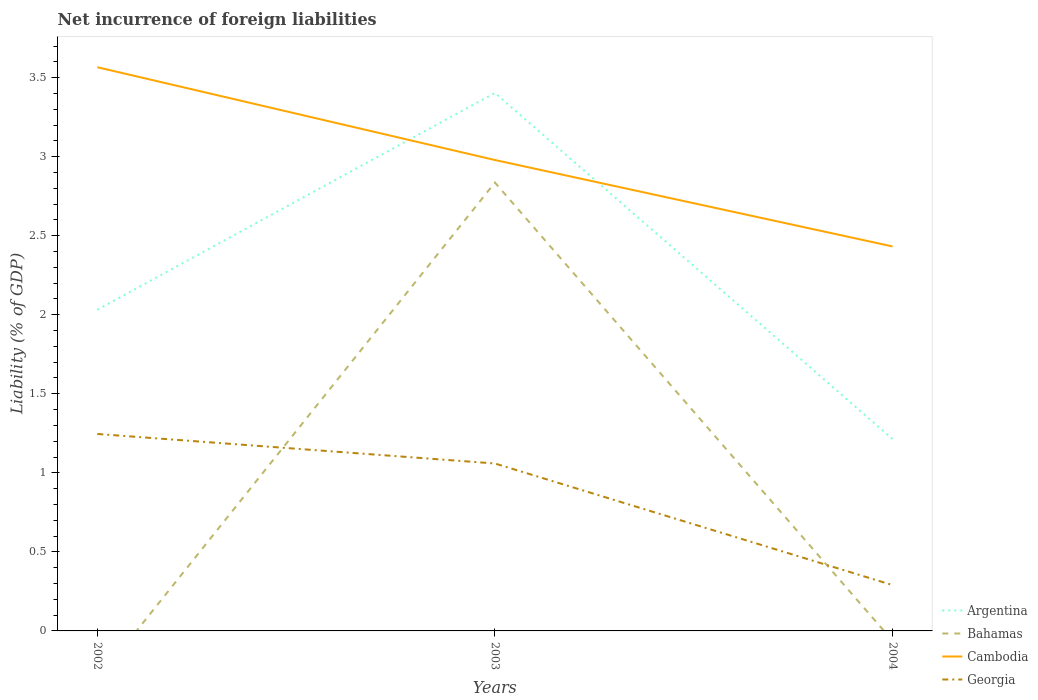Does the line corresponding to Georgia intersect with the line corresponding to Bahamas?
Provide a succinct answer. Yes. Is the number of lines equal to the number of legend labels?
Provide a succinct answer. No. Across all years, what is the maximum net incurrence of foreign liabilities in Argentina?
Give a very brief answer. 1.21. What is the total net incurrence of foreign liabilities in Georgia in the graph?
Keep it short and to the point. 0.96. What is the difference between the highest and the second highest net incurrence of foreign liabilities in Argentina?
Keep it short and to the point. 2.19. Is the net incurrence of foreign liabilities in Bahamas strictly greater than the net incurrence of foreign liabilities in Argentina over the years?
Keep it short and to the point. Yes. What is the difference between two consecutive major ticks on the Y-axis?
Your answer should be very brief. 0.5. Are the values on the major ticks of Y-axis written in scientific E-notation?
Offer a terse response. No. Does the graph contain any zero values?
Provide a short and direct response. Yes. Does the graph contain grids?
Provide a short and direct response. No. How are the legend labels stacked?
Your answer should be very brief. Vertical. What is the title of the graph?
Keep it short and to the point. Net incurrence of foreign liabilities. What is the label or title of the Y-axis?
Offer a terse response. Liability (% of GDP). What is the Liability (% of GDP) of Argentina in 2002?
Offer a very short reply. 2.03. What is the Liability (% of GDP) in Cambodia in 2002?
Your answer should be compact. 3.57. What is the Liability (% of GDP) of Georgia in 2002?
Provide a succinct answer. 1.25. What is the Liability (% of GDP) of Argentina in 2003?
Make the answer very short. 3.4. What is the Liability (% of GDP) of Bahamas in 2003?
Offer a very short reply. 2.84. What is the Liability (% of GDP) of Cambodia in 2003?
Your answer should be very brief. 2.98. What is the Liability (% of GDP) in Georgia in 2003?
Offer a very short reply. 1.06. What is the Liability (% of GDP) in Argentina in 2004?
Give a very brief answer. 1.21. What is the Liability (% of GDP) in Cambodia in 2004?
Offer a terse response. 2.43. What is the Liability (% of GDP) in Georgia in 2004?
Offer a very short reply. 0.29. Across all years, what is the maximum Liability (% of GDP) of Argentina?
Give a very brief answer. 3.4. Across all years, what is the maximum Liability (% of GDP) in Bahamas?
Ensure brevity in your answer.  2.84. Across all years, what is the maximum Liability (% of GDP) of Cambodia?
Make the answer very short. 3.57. Across all years, what is the maximum Liability (% of GDP) of Georgia?
Make the answer very short. 1.25. Across all years, what is the minimum Liability (% of GDP) of Argentina?
Your answer should be compact. 1.21. Across all years, what is the minimum Liability (% of GDP) in Bahamas?
Your response must be concise. 0. Across all years, what is the minimum Liability (% of GDP) of Cambodia?
Keep it short and to the point. 2.43. Across all years, what is the minimum Liability (% of GDP) in Georgia?
Your response must be concise. 0.29. What is the total Liability (% of GDP) in Argentina in the graph?
Provide a succinct answer. 6.65. What is the total Liability (% of GDP) of Bahamas in the graph?
Provide a succinct answer. 2.84. What is the total Liability (% of GDP) in Cambodia in the graph?
Offer a very short reply. 8.98. What is the total Liability (% of GDP) in Georgia in the graph?
Provide a short and direct response. 2.6. What is the difference between the Liability (% of GDP) of Argentina in 2002 and that in 2003?
Your answer should be compact. -1.37. What is the difference between the Liability (% of GDP) in Cambodia in 2002 and that in 2003?
Provide a succinct answer. 0.59. What is the difference between the Liability (% of GDP) in Georgia in 2002 and that in 2003?
Offer a very short reply. 0.19. What is the difference between the Liability (% of GDP) in Argentina in 2002 and that in 2004?
Your response must be concise. 0.82. What is the difference between the Liability (% of GDP) of Cambodia in 2002 and that in 2004?
Offer a very short reply. 1.13. What is the difference between the Liability (% of GDP) of Georgia in 2002 and that in 2004?
Make the answer very short. 0.96. What is the difference between the Liability (% of GDP) in Argentina in 2003 and that in 2004?
Offer a very short reply. 2.19. What is the difference between the Liability (% of GDP) of Cambodia in 2003 and that in 2004?
Ensure brevity in your answer.  0.55. What is the difference between the Liability (% of GDP) in Georgia in 2003 and that in 2004?
Provide a short and direct response. 0.77. What is the difference between the Liability (% of GDP) in Argentina in 2002 and the Liability (% of GDP) in Bahamas in 2003?
Offer a very short reply. -0.8. What is the difference between the Liability (% of GDP) in Argentina in 2002 and the Liability (% of GDP) in Cambodia in 2003?
Your answer should be very brief. -0.95. What is the difference between the Liability (% of GDP) in Argentina in 2002 and the Liability (% of GDP) in Georgia in 2003?
Your response must be concise. 0.97. What is the difference between the Liability (% of GDP) of Cambodia in 2002 and the Liability (% of GDP) of Georgia in 2003?
Your answer should be very brief. 2.51. What is the difference between the Liability (% of GDP) of Argentina in 2002 and the Liability (% of GDP) of Cambodia in 2004?
Make the answer very short. -0.4. What is the difference between the Liability (% of GDP) in Argentina in 2002 and the Liability (% of GDP) in Georgia in 2004?
Provide a succinct answer. 1.74. What is the difference between the Liability (% of GDP) of Cambodia in 2002 and the Liability (% of GDP) of Georgia in 2004?
Give a very brief answer. 3.28. What is the difference between the Liability (% of GDP) of Argentina in 2003 and the Liability (% of GDP) of Cambodia in 2004?
Make the answer very short. 0.97. What is the difference between the Liability (% of GDP) in Argentina in 2003 and the Liability (% of GDP) in Georgia in 2004?
Offer a terse response. 3.11. What is the difference between the Liability (% of GDP) in Bahamas in 2003 and the Liability (% of GDP) in Cambodia in 2004?
Ensure brevity in your answer.  0.4. What is the difference between the Liability (% of GDP) of Bahamas in 2003 and the Liability (% of GDP) of Georgia in 2004?
Offer a terse response. 2.55. What is the difference between the Liability (% of GDP) in Cambodia in 2003 and the Liability (% of GDP) in Georgia in 2004?
Give a very brief answer. 2.69. What is the average Liability (% of GDP) in Argentina per year?
Give a very brief answer. 2.22. What is the average Liability (% of GDP) in Bahamas per year?
Offer a terse response. 0.95. What is the average Liability (% of GDP) of Cambodia per year?
Ensure brevity in your answer.  2.99. What is the average Liability (% of GDP) in Georgia per year?
Provide a succinct answer. 0.86. In the year 2002, what is the difference between the Liability (% of GDP) of Argentina and Liability (% of GDP) of Cambodia?
Offer a terse response. -1.53. In the year 2002, what is the difference between the Liability (% of GDP) in Argentina and Liability (% of GDP) in Georgia?
Provide a short and direct response. 0.79. In the year 2002, what is the difference between the Liability (% of GDP) in Cambodia and Liability (% of GDP) in Georgia?
Offer a terse response. 2.32. In the year 2003, what is the difference between the Liability (% of GDP) in Argentina and Liability (% of GDP) in Bahamas?
Keep it short and to the point. 0.57. In the year 2003, what is the difference between the Liability (% of GDP) in Argentina and Liability (% of GDP) in Cambodia?
Give a very brief answer. 0.42. In the year 2003, what is the difference between the Liability (% of GDP) in Argentina and Liability (% of GDP) in Georgia?
Ensure brevity in your answer.  2.34. In the year 2003, what is the difference between the Liability (% of GDP) of Bahamas and Liability (% of GDP) of Cambodia?
Ensure brevity in your answer.  -0.14. In the year 2003, what is the difference between the Liability (% of GDP) of Bahamas and Liability (% of GDP) of Georgia?
Your response must be concise. 1.78. In the year 2003, what is the difference between the Liability (% of GDP) of Cambodia and Liability (% of GDP) of Georgia?
Offer a very short reply. 1.92. In the year 2004, what is the difference between the Liability (% of GDP) of Argentina and Liability (% of GDP) of Cambodia?
Your response must be concise. -1.22. In the year 2004, what is the difference between the Liability (% of GDP) of Argentina and Liability (% of GDP) of Georgia?
Your answer should be compact. 0.92. In the year 2004, what is the difference between the Liability (% of GDP) in Cambodia and Liability (% of GDP) in Georgia?
Give a very brief answer. 2.14. What is the ratio of the Liability (% of GDP) of Argentina in 2002 to that in 2003?
Keep it short and to the point. 0.6. What is the ratio of the Liability (% of GDP) in Cambodia in 2002 to that in 2003?
Offer a very short reply. 1.2. What is the ratio of the Liability (% of GDP) in Georgia in 2002 to that in 2003?
Offer a terse response. 1.18. What is the ratio of the Liability (% of GDP) of Argentina in 2002 to that in 2004?
Give a very brief answer. 1.67. What is the ratio of the Liability (% of GDP) in Cambodia in 2002 to that in 2004?
Ensure brevity in your answer.  1.47. What is the ratio of the Liability (% of GDP) of Georgia in 2002 to that in 2004?
Your answer should be compact. 4.29. What is the ratio of the Liability (% of GDP) in Argentina in 2003 to that in 2004?
Your response must be concise. 2.8. What is the ratio of the Liability (% of GDP) of Cambodia in 2003 to that in 2004?
Your answer should be very brief. 1.22. What is the ratio of the Liability (% of GDP) in Georgia in 2003 to that in 2004?
Your answer should be compact. 3.65. What is the difference between the highest and the second highest Liability (% of GDP) of Argentina?
Keep it short and to the point. 1.37. What is the difference between the highest and the second highest Liability (% of GDP) in Cambodia?
Your response must be concise. 0.59. What is the difference between the highest and the second highest Liability (% of GDP) of Georgia?
Make the answer very short. 0.19. What is the difference between the highest and the lowest Liability (% of GDP) of Argentina?
Make the answer very short. 2.19. What is the difference between the highest and the lowest Liability (% of GDP) in Bahamas?
Provide a short and direct response. 2.84. What is the difference between the highest and the lowest Liability (% of GDP) in Cambodia?
Your answer should be compact. 1.13. What is the difference between the highest and the lowest Liability (% of GDP) of Georgia?
Offer a terse response. 0.96. 